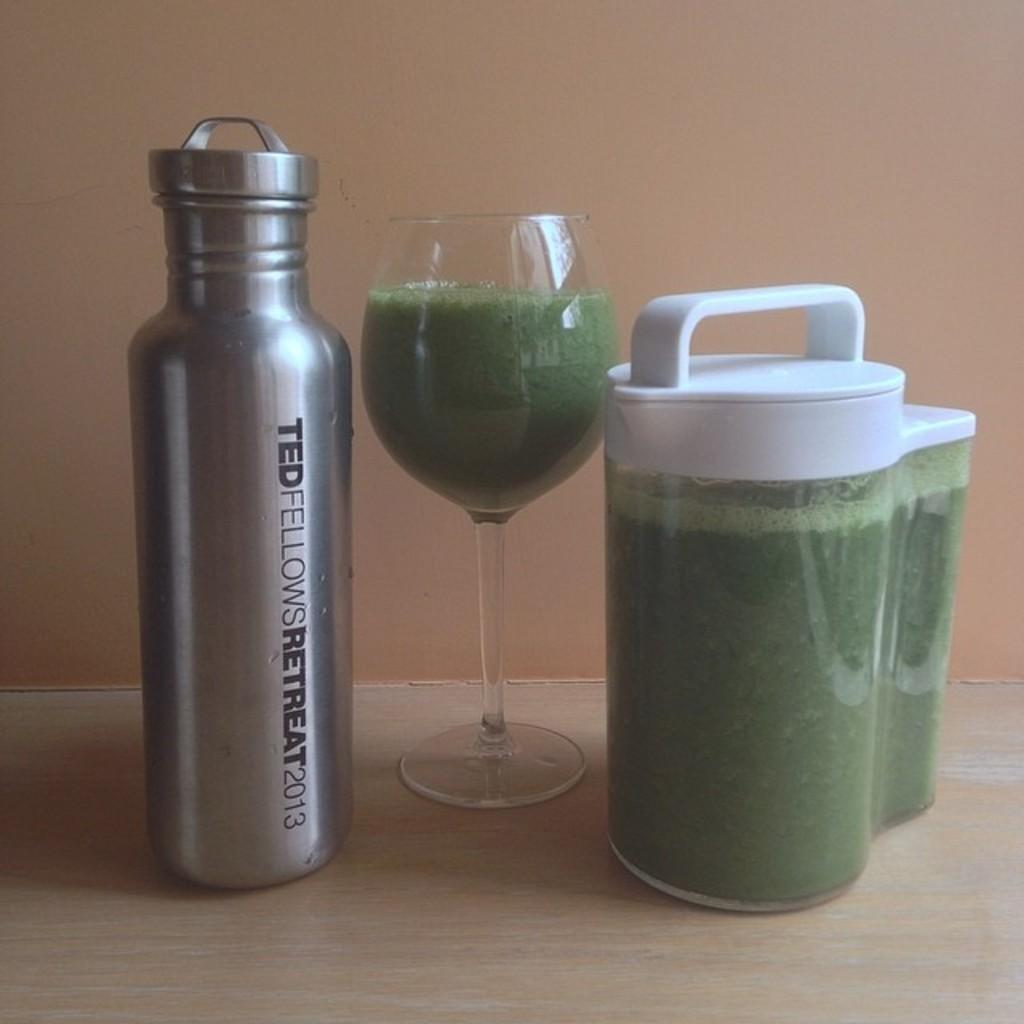<image>
Share a concise interpretation of the image provided. A mettle bottle that is from a 2013 Ted Fellows Retreat. 